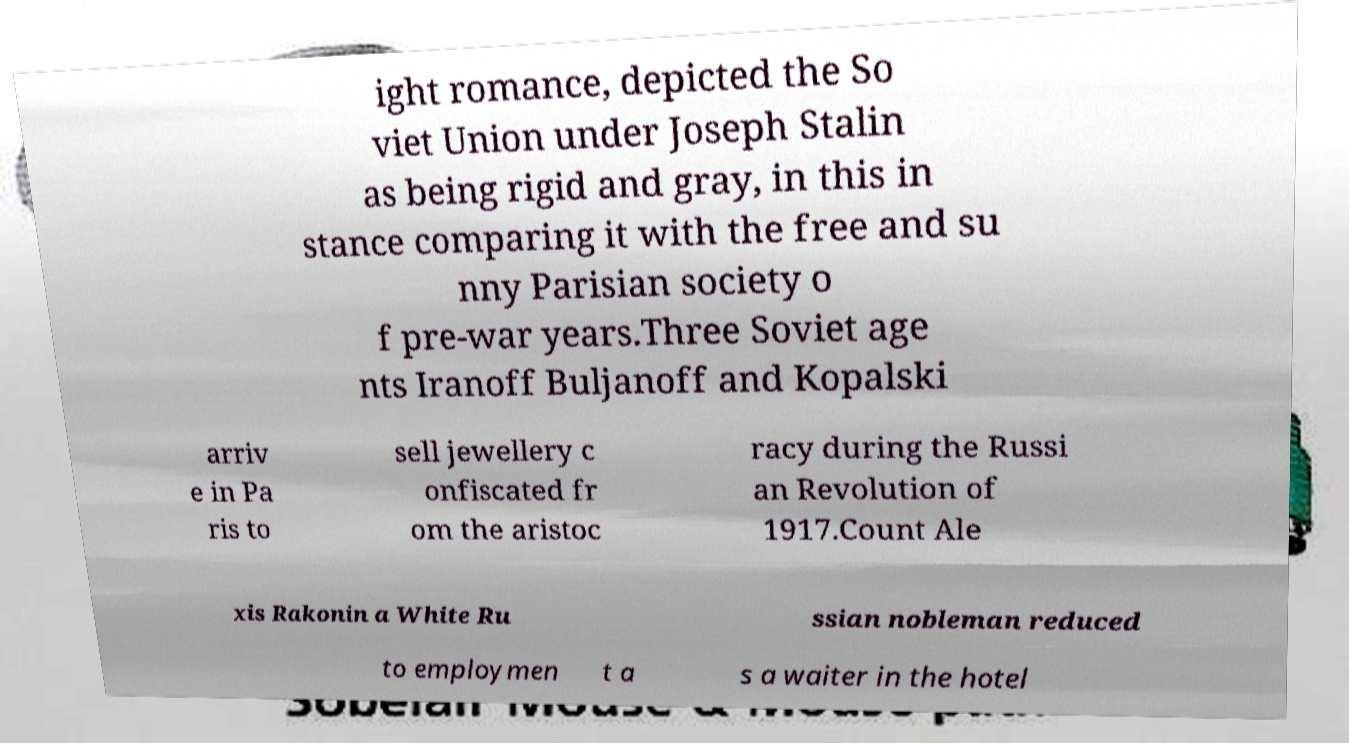Can you read and provide the text displayed in the image?This photo seems to have some interesting text. Can you extract and type it out for me? ight romance, depicted the So viet Union under Joseph Stalin as being rigid and gray, in this in stance comparing it with the free and su nny Parisian society o f pre-war years.Three Soviet age nts Iranoff Buljanoff and Kopalski arriv e in Pa ris to sell jewellery c onfiscated fr om the aristoc racy during the Russi an Revolution of 1917.Count Ale xis Rakonin a White Ru ssian nobleman reduced to employmen t a s a waiter in the hotel 